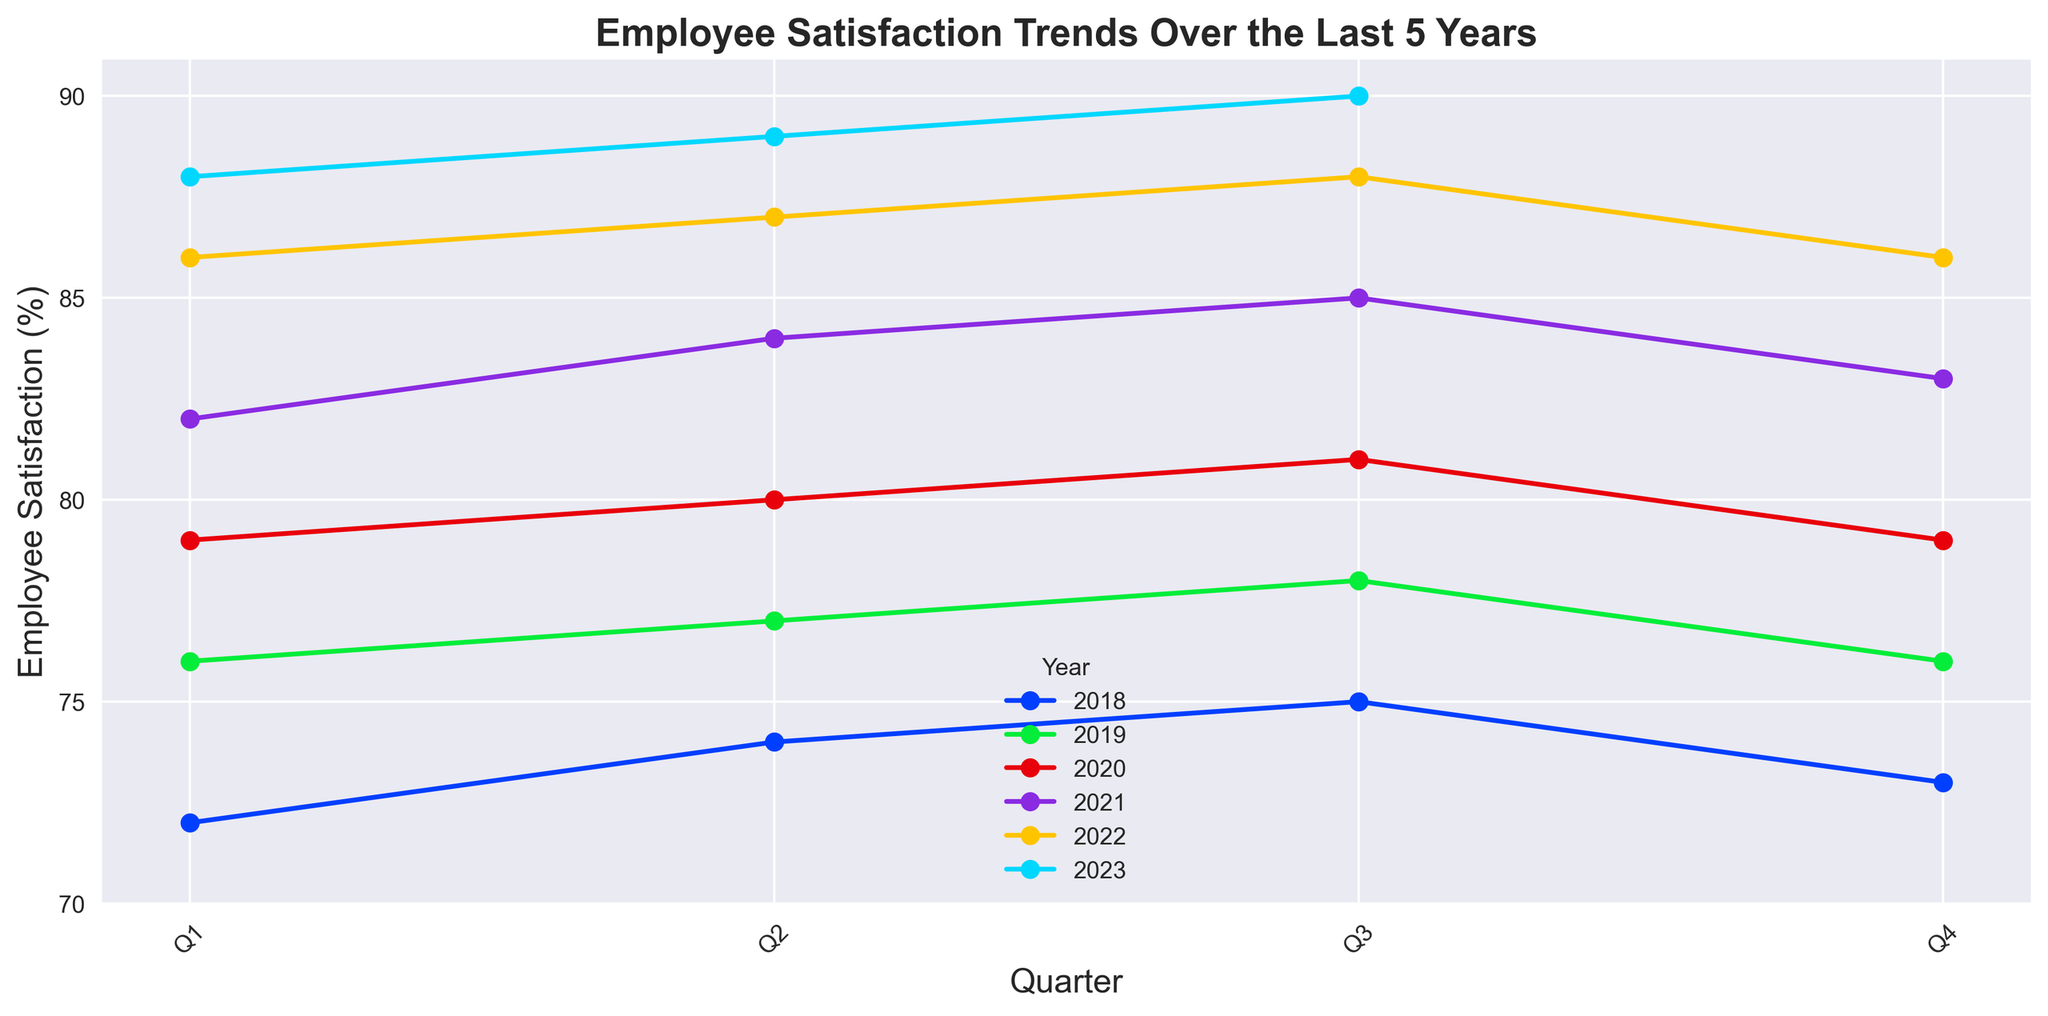What is the employee satisfaction percentage in Q3 2019? To find the employee satisfaction percentage in Q3 2019, look at the data point for Q3 in the year 2019.
Answer: 78 Which quarter shows the highest employee satisfaction across all years? Review the graph to identify the peak points across all the quarters and years. The highest value is in Q3 2023.
Answer: Q3 2023 By how much did employee satisfaction change from Q4 2018 to Q1 2019? Locate the values for Q4 2018 and Q1 2019. Subtract the value of Q4 2018 (73) from Q1 2019 (76). 76 - 73 = 3
Answer: 3 What is the average employee satisfaction for the year 2020? Sum the values of each quarter in 2020 (Q1: 79, Q2: 80, Q3: 81, Q4: 79) and divide by the number of quarters (4). (79 + 80 + 81 + 79) / 4 = 319 / 4 = 79.75
Answer: 79.75 Which year showed the most improvement in employee satisfaction from Q1 to Q4? Calculate the difference between Q1 and Q4 for each year. Identify the year with the largest positive difference. 2020: 79 to 79 (0), 2019: 76 to 76 (0), 2021: 82 to 83 (1), 2022: 86 to 86 (0), 2023: 88 to 90 (2). The year is 2023.
Answer: 2023 How does satisfaction in Q2 2021 compare to Q2 2020? Locate the values for Q2 in 2021 (84) and 2020 (80). Compare them. 84 is higher than 80.
Answer: 84 is higher Can you identify any year where employee satisfaction grew consistently each quarter? Look at the trend lines for each year and identify any year where the satisfaction values increased consistently in all four quarters. 2018 and 2023 show consistent growth.
Answer: 2018 and 2023 What is the median employee satisfaction value in 2023 up to Q3? List the satisfaction values for 2023 (Q1: 88, Q2: 89, Q3: 90), sort them and find the middle value, which is 89.
Answer: 89 Which quarter of 2022 had the highest employee satisfaction? Locate the peak point in 2022. The highest value appears in Q3 2022, which is 88.
Answer: Q3 By how many percentage points did employee satisfaction increase from Q1 2020 to Q3 2023? Identify the values for Q1 2020 (79) and Q3 2023 (90). Subtract the value of Q1 2020 from Q3 2023. 90 - 79 = 11
Answer: 11 